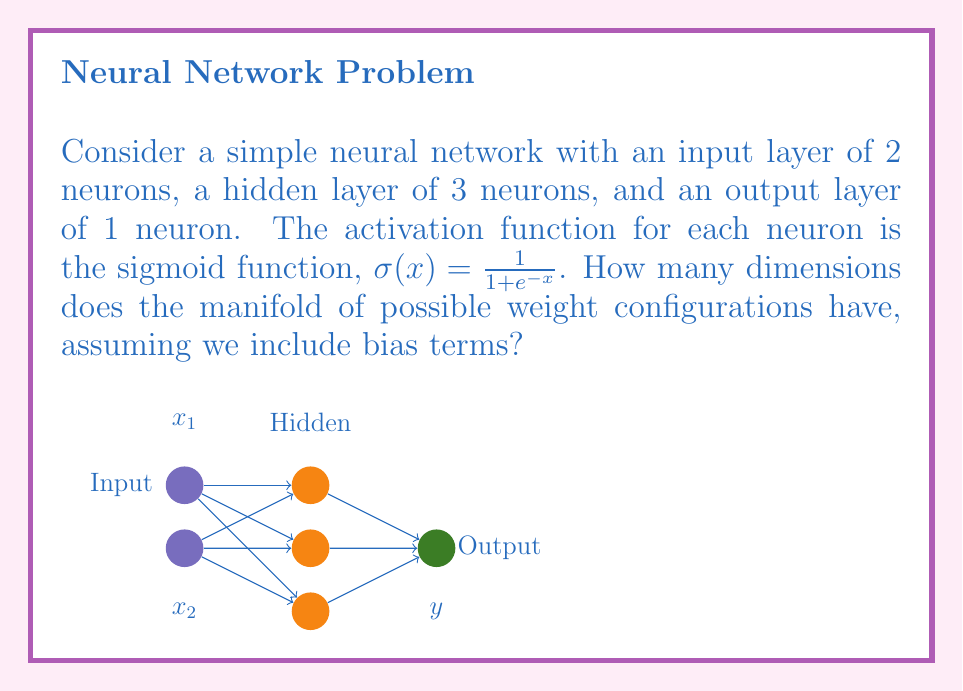Provide a solution to this math problem. Let's break this down step-by-step:

1) First, we need to count the number of weights and biases in the network:

   - From input to hidden layer:
     * Each of the 2 input neurons connects to each of the 3 hidden neurons: 2 * 3 = 6 weights
     * Each hidden neuron has a bias: 3 biases

   - From hidden to output layer:
     * Each of the 3 hidden neurons connects to the 1 output neuron: 3 * 1 = 3 weights
     * The output neuron has a bias: 1 bias

2) Now, let's sum up all the parameters:
   * Input to hidden: 6 weights + 3 biases = 9 parameters
   * Hidden to output: 3 weights + 1 bias = 4 parameters
   * Total: 9 + 4 = 13 parameters

3) In the context of neural networks, each parameter can be thought of as a dimension in the space of possible configurations. This is because each parameter can be adjusted independently of the others.

4) The manifold of possible weight configurations is therefore a 13-dimensional space. Each point in this space represents a unique configuration of the neural network's weights and biases.

5) It's worth noting that while this space is 13-dimensional, the actual decision boundary created by the network in the input space is much lower-dimensional (in this case, it separates the 2D input space).

6) The topology of this manifold is complex. While it's technically a subset of $\mathbb{R}^{13}$, the use of the sigmoid activation function means that some regions of this space (where the weights are very large or very small) will have little effect on the network's output, creating interesting topological features.
Answer: 13-dimensional manifold 